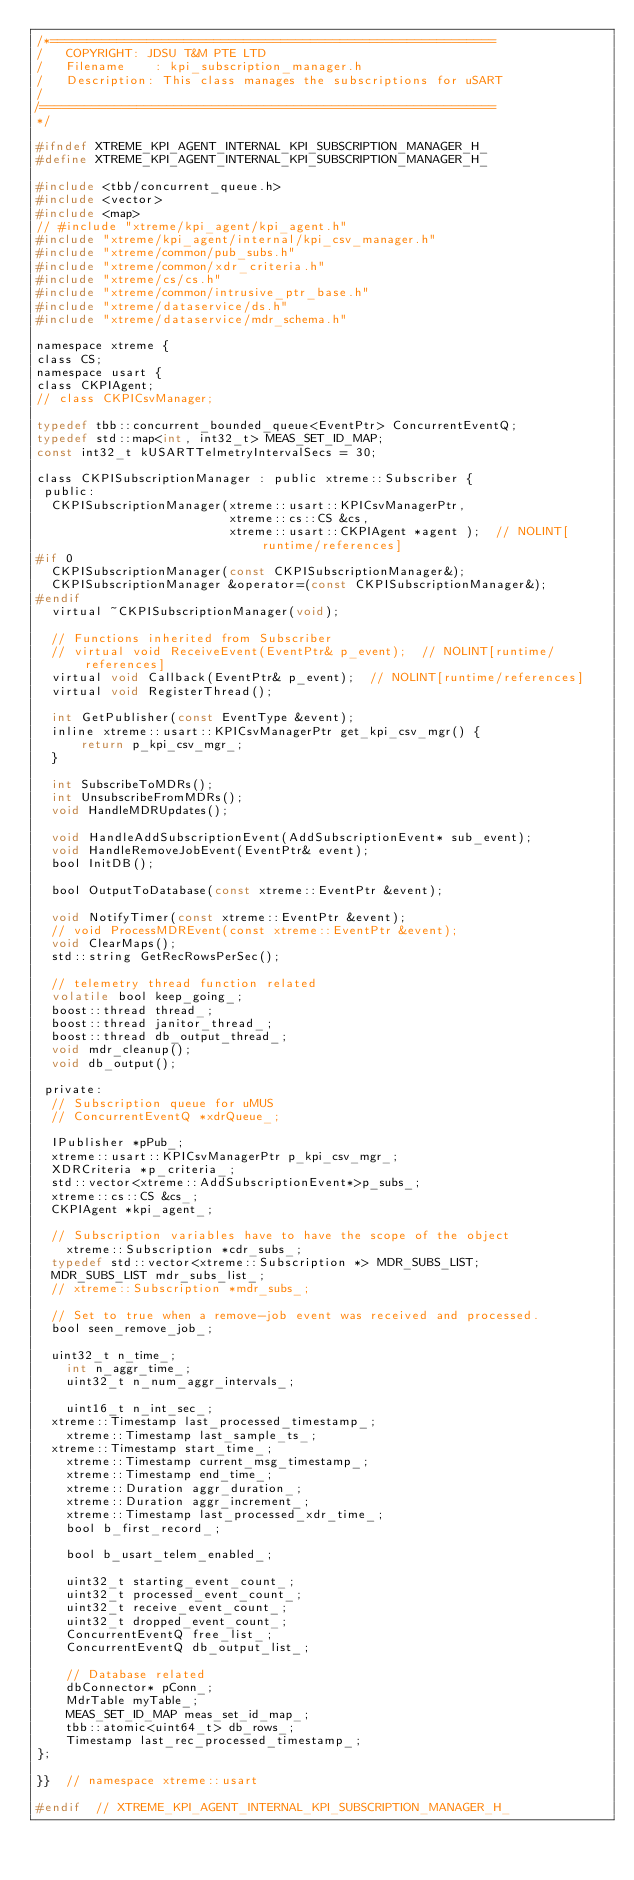Convert code to text. <code><loc_0><loc_0><loc_500><loc_500><_C_>/*============================================================
/   COPYRIGHT: JDSU T&M PTE LTD
/   Filename    : kpi_subscription_manager.h
/   Description: This class manages the subscriptions for uSART
/
/=============================================================
*/

#ifndef XTREME_KPI_AGENT_INTERNAL_KPI_SUBSCRIPTION_MANAGER_H_
#define XTREME_KPI_AGENT_INTERNAL_KPI_SUBSCRIPTION_MANAGER_H_

#include <tbb/concurrent_queue.h>
#include <vector>
#include <map>
// #include "xtreme/kpi_agent/kpi_agent.h"
#include "xtreme/kpi_agent/internal/kpi_csv_manager.h"
#include "xtreme/common/pub_subs.h"
#include "xtreme/common/xdr_criteria.h"
#include "xtreme/cs/cs.h"
#include "xtreme/common/intrusive_ptr_base.h"
#include "xtreme/dataservice/ds.h"
#include "xtreme/dataservice/mdr_schema.h"

namespace xtreme {
class CS;
namespace usart {
class CKPIAgent;
// class CKPICsvManager;

typedef tbb::concurrent_bounded_queue<EventPtr> ConcurrentEventQ;
typedef std::map<int, int32_t> MEAS_SET_ID_MAP;
const int32_t kUSARTTelmetryIntervalSecs = 30;

class CKPISubscriptionManager : public xtreme::Subscriber {
 public:
  CKPISubscriptionManager(xtreme::usart::KPICsvManagerPtr,
                          xtreme::cs::CS &cs,
                          xtreme::usart::CKPIAgent *agent );  // NOLINT[runtime/references]
#if 0
  CKPISubscriptionManager(const CKPISubscriptionManager&);
  CKPISubscriptionManager &operator=(const CKPISubscriptionManager&);
#endif
  virtual ~CKPISubscriptionManager(void);

  // Functions inherited from Subscriber
  // virtual void ReceiveEvent(EventPtr& p_event);  // NOLINT[runtime/references]
  virtual void Callback(EventPtr& p_event);  // NOLINT[runtime/references]
  virtual void RegisterThread();

  int GetPublisher(const EventType &event);
  inline xtreme::usart::KPICsvManagerPtr get_kpi_csv_mgr() {
      return p_kpi_csv_mgr_;
  }

  int SubscribeToMDRs();
  int UnsubscribeFromMDRs();
  void HandleMDRUpdates();

  void HandleAddSubscriptionEvent(AddSubscriptionEvent* sub_event);
  void HandleRemoveJobEvent(EventPtr& event);
  bool InitDB();

  bool OutputToDatabase(const xtreme::EventPtr &event);

  void NotifyTimer(const xtreme::EventPtr &event);
  // void ProcessMDREvent(const xtreme::EventPtr &event);
  void ClearMaps();
  std::string GetRecRowsPerSec();

  // telemetry thread function related
  volatile bool keep_going_;
  boost::thread thread_;
  boost::thread janitor_thread_;
  boost::thread db_output_thread_;
  void mdr_cleanup();
  void db_output();

 private:
  // Subscription queue for uMUS
  // ConcurrentEventQ *xdrQueue_;

  IPublisher *pPub_;
  xtreme::usart::KPICsvManagerPtr p_kpi_csv_mgr_;
  XDRCriteria *p_criteria_;
  std::vector<xtreme::AddSubscriptionEvent*>p_subs_;
  xtreme::cs::CS &cs_;
  CKPIAgent *kpi_agent_;

  // Subscription variables have to have the scope of the object
    xtreme::Subscription *cdr_subs_;
  typedef std::vector<xtreme::Subscription *> MDR_SUBS_LIST;
  MDR_SUBS_LIST mdr_subs_list_;
  // xtreme::Subscription *mdr_subs_;

  // Set to true when a remove-job event was received and processed.
  bool seen_remove_job_;

  uint32_t n_time_;
    int n_aggr_time_;
    uint32_t n_num_aggr_intervals_;

    uint16_t n_int_sec_;
  xtreme::Timestamp last_processed_timestamp_;
    xtreme::Timestamp last_sample_ts_;
  xtreme::Timestamp start_time_;
    xtreme::Timestamp current_msg_timestamp_;
    xtreme::Timestamp end_time_;
    xtreme::Duration aggr_duration_;
    xtreme::Duration aggr_increment_;
    xtreme::Timestamp last_processed_xdr_time_;
    bool b_first_record_;

    bool b_usart_telem_enabled_;

    uint32_t starting_event_count_;
    uint32_t processed_event_count_;
    uint32_t receive_event_count_;
    uint32_t dropped_event_count_;
    ConcurrentEventQ free_list_;
    ConcurrentEventQ db_output_list_;

    // Database related
    dbConnector* pConn_;
    MdrTable myTable_;
    MEAS_SET_ID_MAP meas_set_id_map_;
    tbb::atomic<uint64_t> db_rows_;
    Timestamp last_rec_processed_timestamp_;
};

}}  // namespace xtreme::usart

#endif  // XTREME_KPI_AGENT_INTERNAL_KPI_SUBSCRIPTION_MANAGER_H_
</code> 